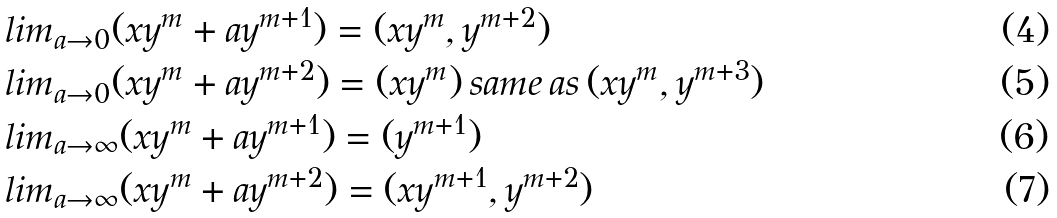Convert formula to latex. <formula><loc_0><loc_0><loc_500><loc_500>& l i m _ { a \rightarrow 0 } ( x y ^ { m } + a y ^ { m + 1 } ) = ( x y ^ { m } , y ^ { m + 2 } ) \\ & l i m _ { a \rightarrow 0 } ( x y ^ { m } + a y ^ { m + 2 } ) = ( x y ^ { m } ) \, s a m e \, a s \, ( x y ^ { m } , y ^ { m + 3 } ) \\ & l i m _ { a \rightarrow \infty } ( x y ^ { m } + a y ^ { m + 1 } ) = ( y ^ { m + 1 } ) \\ & l i m _ { a \rightarrow \infty } ( x y ^ { m } + a y ^ { m + 2 } ) = ( x y ^ { m + 1 } , y ^ { m + 2 } )</formula> 